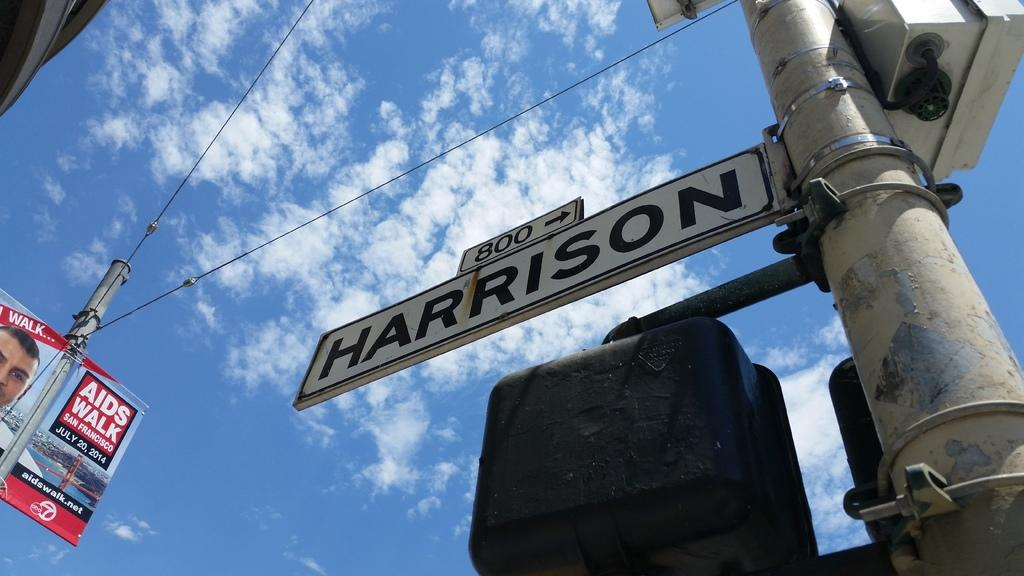Provide a one-sentence caption for the provided image. Looking up at the street sign for Harrison reveals a blue sky. 